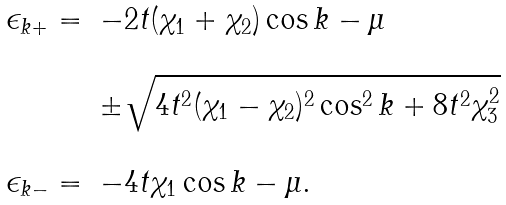Convert formula to latex. <formula><loc_0><loc_0><loc_500><loc_500>\begin{array} { l l } \epsilon _ { k + } = & - 2 t ( \chi _ { 1 } + \chi _ { 2 } ) \cos k - \mu \\ & \\ & \pm \sqrt { 4 t ^ { 2 } ( \chi _ { 1 } - \chi _ { 2 } ) ^ { 2 } \cos ^ { 2 } k + 8 t ^ { 2 } \chi ^ { 2 } _ { 3 } } \\ \\ \epsilon _ { k - } = & - 4 t \chi _ { 1 } \cos k - \mu . \end{array}</formula> 